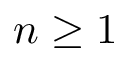<formula> <loc_0><loc_0><loc_500><loc_500>n \geq 1</formula> 